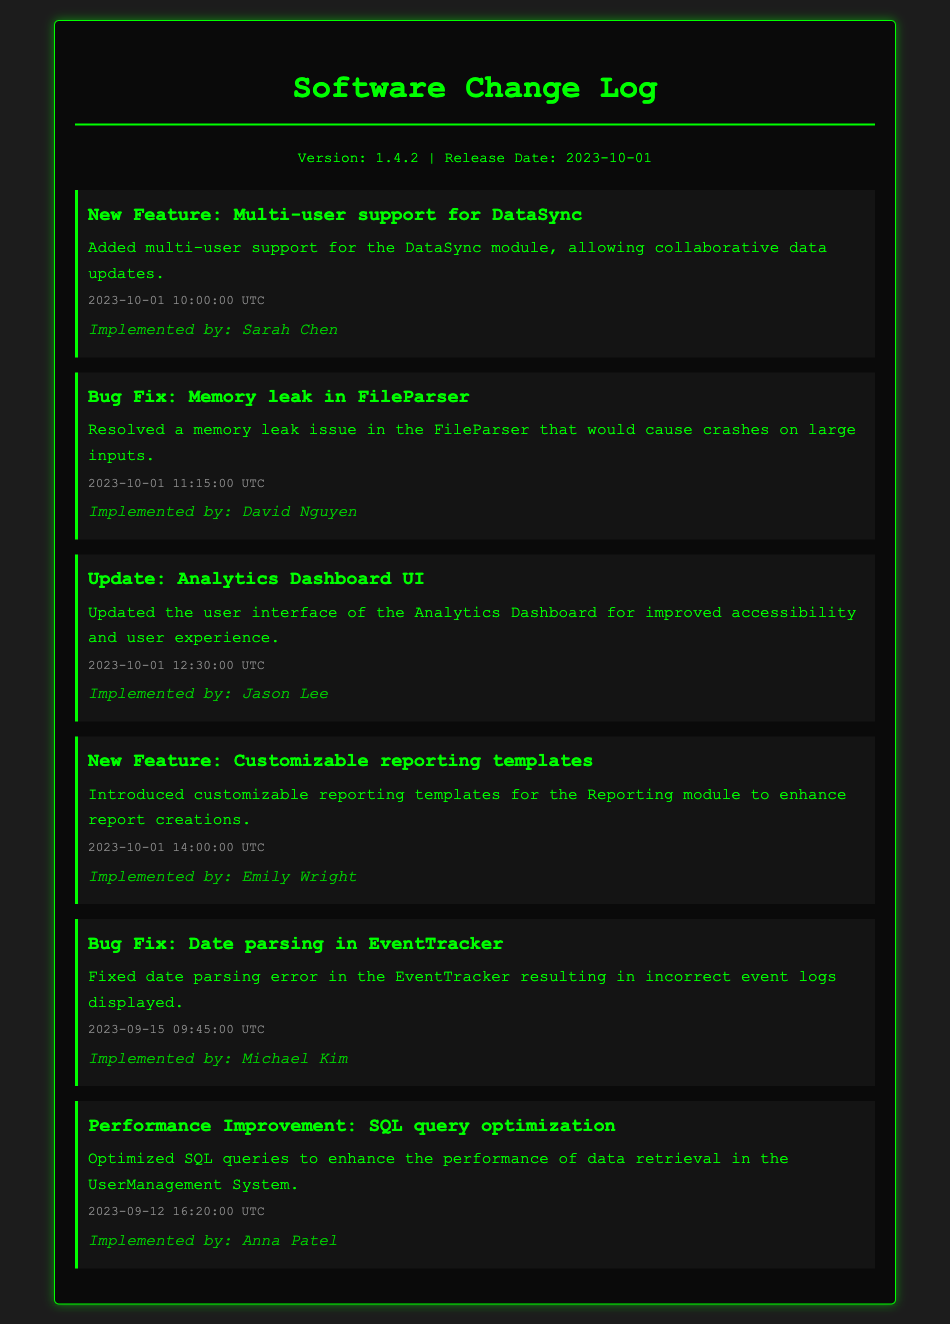What is the version number of the software? The version number is mentioned at the top of the document in the version info section.
Answer: 1.4.2 When was the release date? The release date is found in the version info section, stating when the new software version was released.
Answer: 2023-10-01 What new feature was implemented involving DataSync? The specific change is described in the changelog item about multi-user support for DataSync.
Answer: Multi-user support Who implemented the bug fix for the memory leak? This information is provided in the changelog item detailing the memory leak fix, specifying the person responsible.
Answer: David Nguyen What time was the customizable reporting templates feature added? The timestamp next to the customizable reporting templates changelog item indicates the exact time it was added.
Answer: 14:00:00 UTC What was done to the Analytics Dashboard UI? The changelog mentions an update made to the user interface of the Analytics Dashboard, capturing the nature of the change.
Answer: Improved accessibility How many bug fixes are noted in the document? The count can be determined by counting the changelog items specifically labeled as 'Bug Fix.'
Answer: 2 Which implemented improvement was focused on SQL queries? The performance improvement related to SQL queries is explicitly stated in the changelog section.
Answer: SQL query optimization On what date was the date parsing error in EventTracker fixed? The date associated with the changelog item for the date parsing error in EventTracker provides this information.
Answer: 2023-09-15 